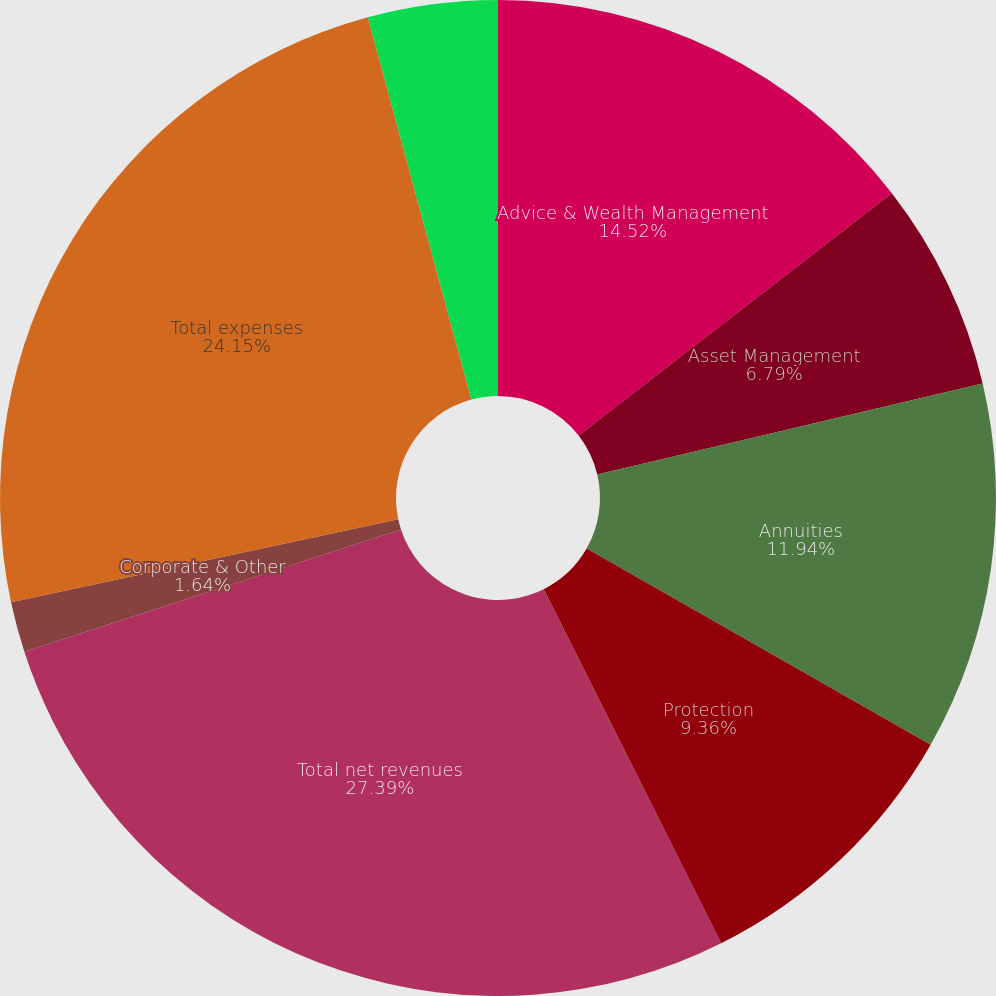Convert chart to OTSL. <chart><loc_0><loc_0><loc_500><loc_500><pie_chart><fcel>Advice & Wealth Management<fcel>Asset Management<fcel>Annuities<fcel>Protection<fcel>Total net revenues<fcel>Corporate & Other<fcel>Total expenses<fcel>Pretax income (loss)<nl><fcel>14.52%<fcel>6.79%<fcel>11.94%<fcel>9.36%<fcel>27.4%<fcel>1.64%<fcel>24.15%<fcel>4.21%<nl></chart> 